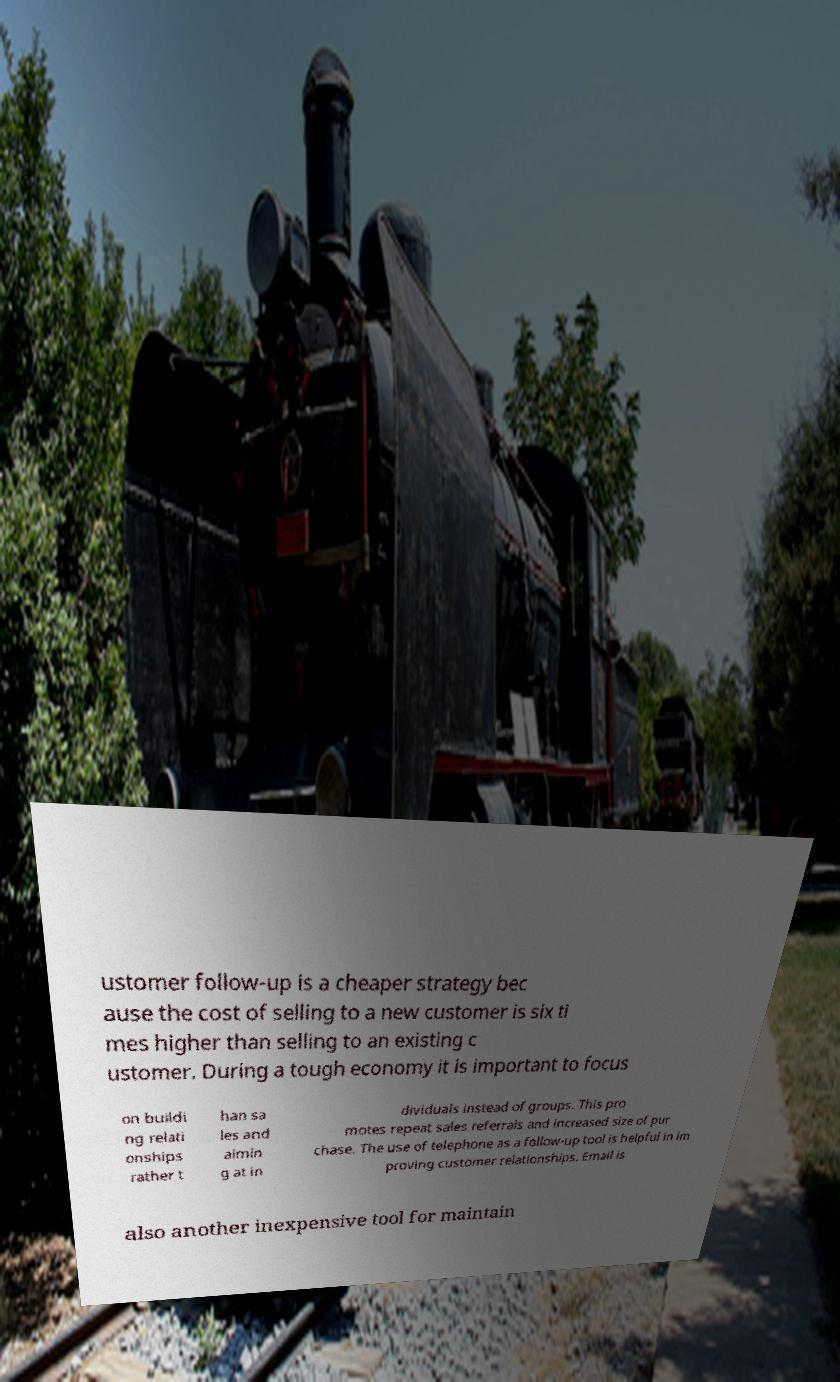I need the written content from this picture converted into text. Can you do that? ustomer follow-up is a cheaper strategy bec ause the cost of selling to a new customer is six ti mes higher than selling to an existing c ustomer. During a tough economy it is important to focus on buildi ng relati onships rather t han sa les and aimin g at in dividuals instead of groups. This pro motes repeat sales referrals and increased size of pur chase. The use of telephone as a follow-up tool is helpful in im proving customer relationships. Email is also another inexpensive tool for maintain 